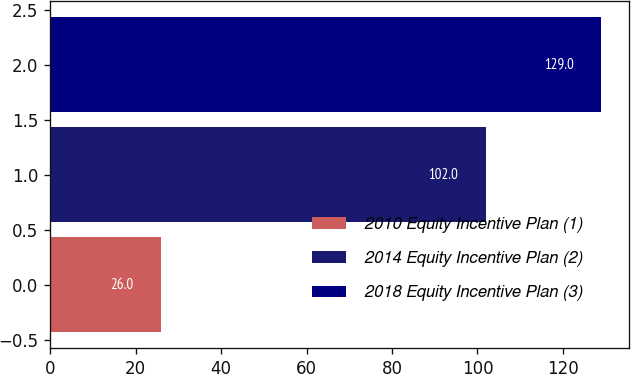<chart> <loc_0><loc_0><loc_500><loc_500><bar_chart><fcel>2010 Equity Incentive Plan (1)<fcel>2014 Equity Incentive Plan (2)<fcel>2018 Equity Incentive Plan (3)<nl><fcel>26<fcel>102<fcel>129<nl></chart> 